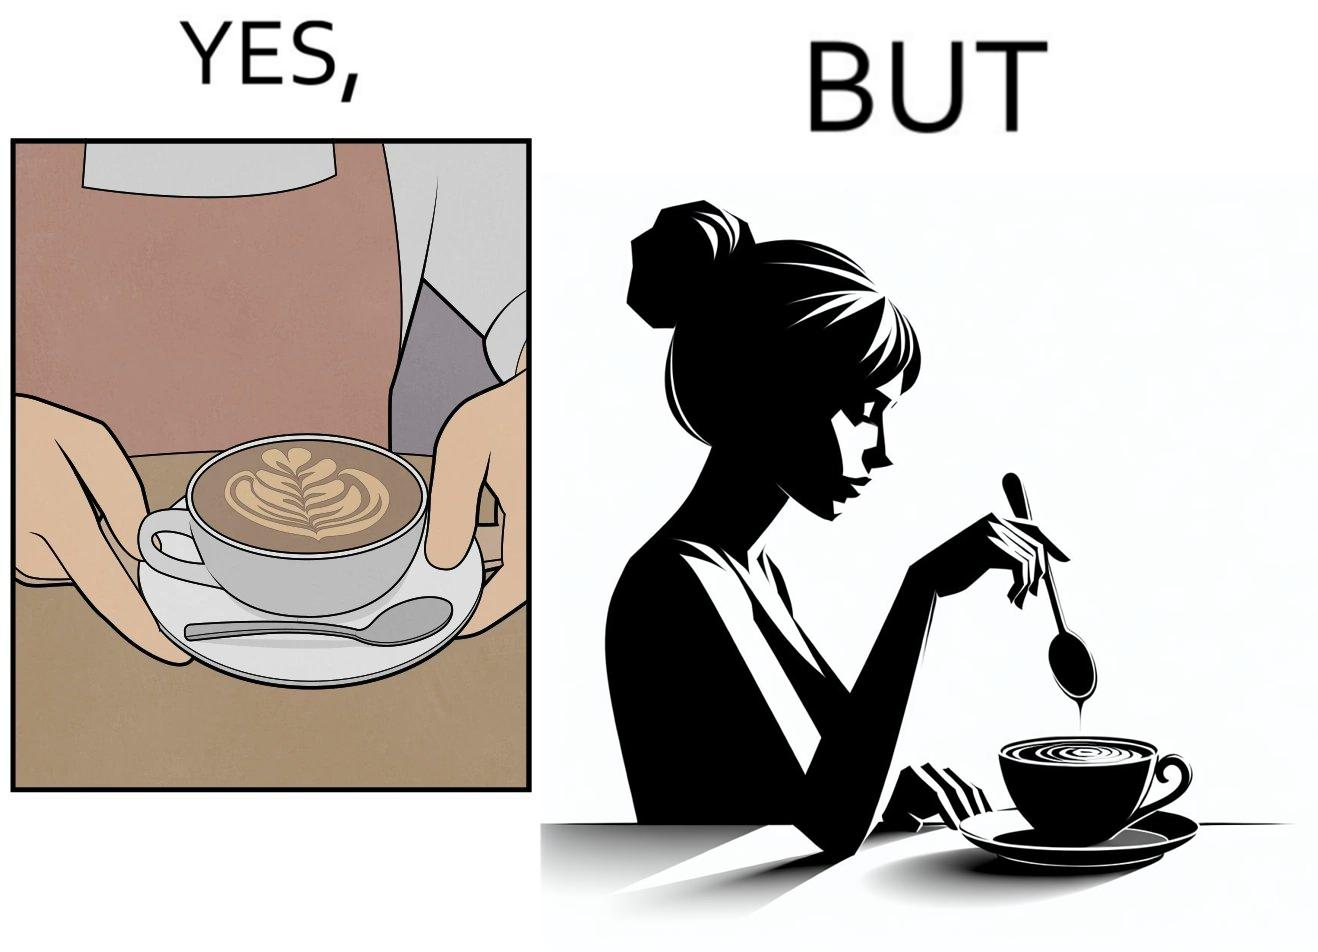Compare the left and right sides of this image. In the left part of the image: a cup of coffee with latte art on it In the right part of the image: a person stirring the coffee with spoon 